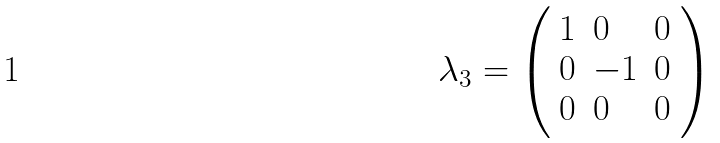<formula> <loc_0><loc_0><loc_500><loc_500>\lambda _ { 3 } = { \left ( \begin{array} { l l l } { 1 } & { 0 } & { 0 } \\ { 0 } & { - 1 } & { 0 } \\ { 0 } & { 0 } & { 0 } \end{array} \right ) }</formula> 